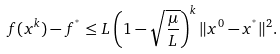Convert formula to latex. <formula><loc_0><loc_0><loc_500><loc_500>f ( x ^ { k } ) - f ^ { ^ { * } } \leq L \left ( 1 - \sqrt { \frac { \mu } { L } } \right ) ^ { k } \| x ^ { 0 } - x ^ { ^ { * } } \| ^ { 2 } .</formula> 